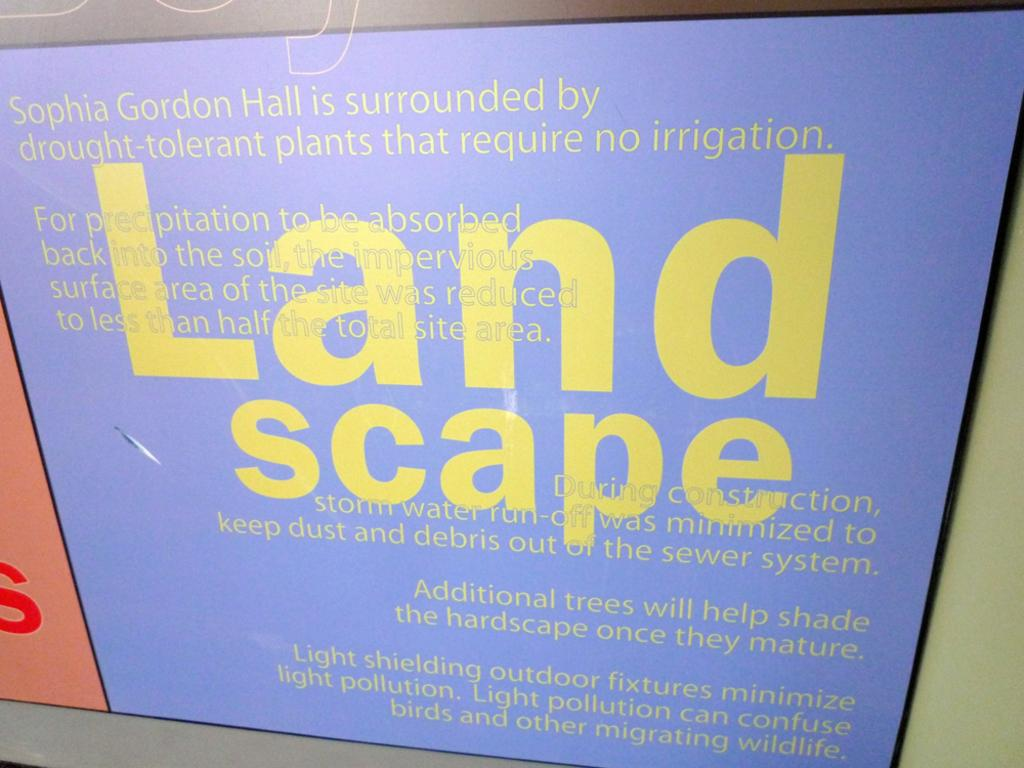<image>
Share a concise interpretation of the image provided. The page displayed is advertising a company called Land scape. 